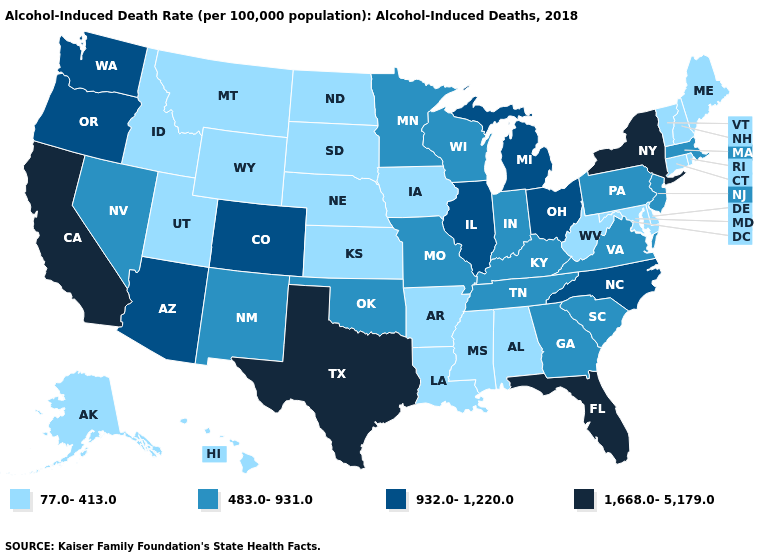Does Virginia have the same value as Washington?
Answer briefly. No. What is the value of Indiana?
Be succinct. 483.0-931.0. Does Wyoming have a lower value than Iowa?
Quick response, please. No. Does Ohio have the lowest value in the MidWest?
Give a very brief answer. No. What is the value of Alabama?
Give a very brief answer. 77.0-413.0. Does Florida have the highest value in the USA?
Keep it brief. Yes. How many symbols are there in the legend?
Answer briefly. 4. Name the states that have a value in the range 483.0-931.0?
Answer briefly. Georgia, Indiana, Kentucky, Massachusetts, Minnesota, Missouri, Nevada, New Jersey, New Mexico, Oklahoma, Pennsylvania, South Carolina, Tennessee, Virginia, Wisconsin. What is the highest value in the USA?
Concise answer only. 1,668.0-5,179.0. Does Maine have the lowest value in the Northeast?
Answer briefly. Yes. What is the lowest value in the USA?
Answer briefly. 77.0-413.0. Does Massachusetts have a higher value than North Carolina?
Be succinct. No. What is the highest value in the West ?
Give a very brief answer. 1,668.0-5,179.0. Name the states that have a value in the range 932.0-1,220.0?
Write a very short answer. Arizona, Colorado, Illinois, Michigan, North Carolina, Ohio, Oregon, Washington. Among the states that border Oklahoma , does New Mexico have the highest value?
Quick response, please. No. 